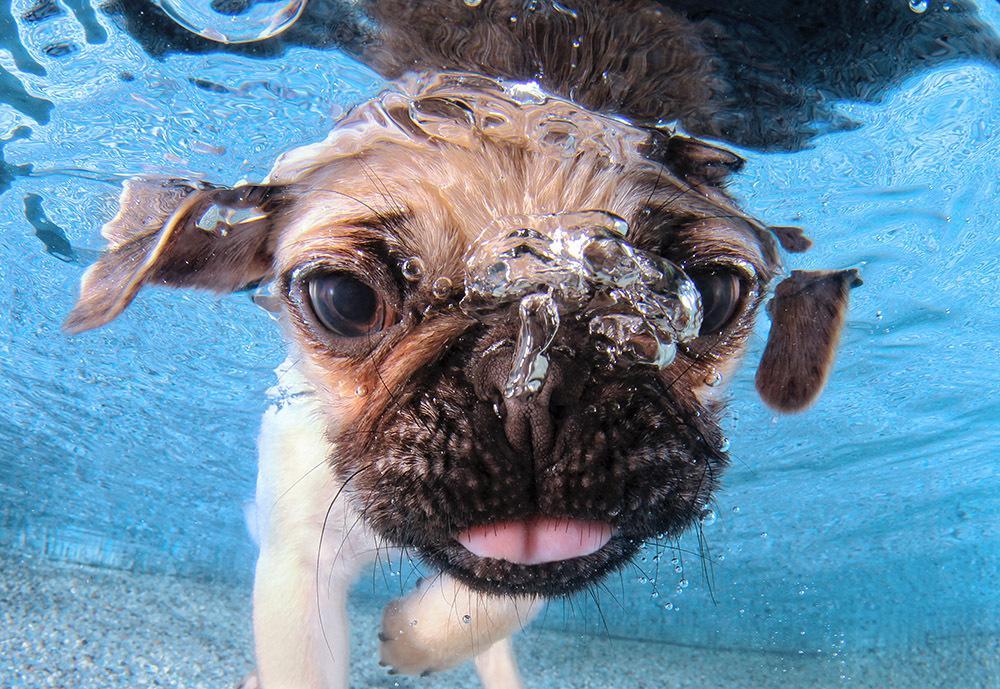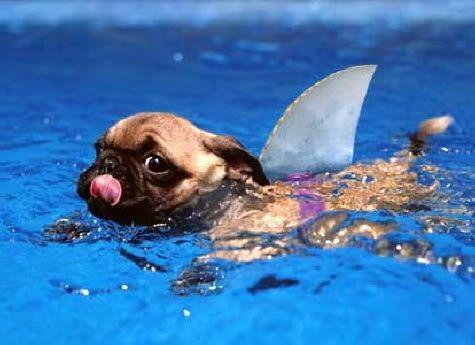The first image is the image on the left, the second image is the image on the right. Assess this claim about the two images: "there is a pug floating in a pool in an inter tube, the tube has a collage of images all over it". Correct or not? Answer yes or no. No. The first image is the image on the left, the second image is the image on the right. Assess this claim about the two images: "In at least one image there is a pug in an intertube with his legs hanging down.". Correct or not? Answer yes or no. No. 